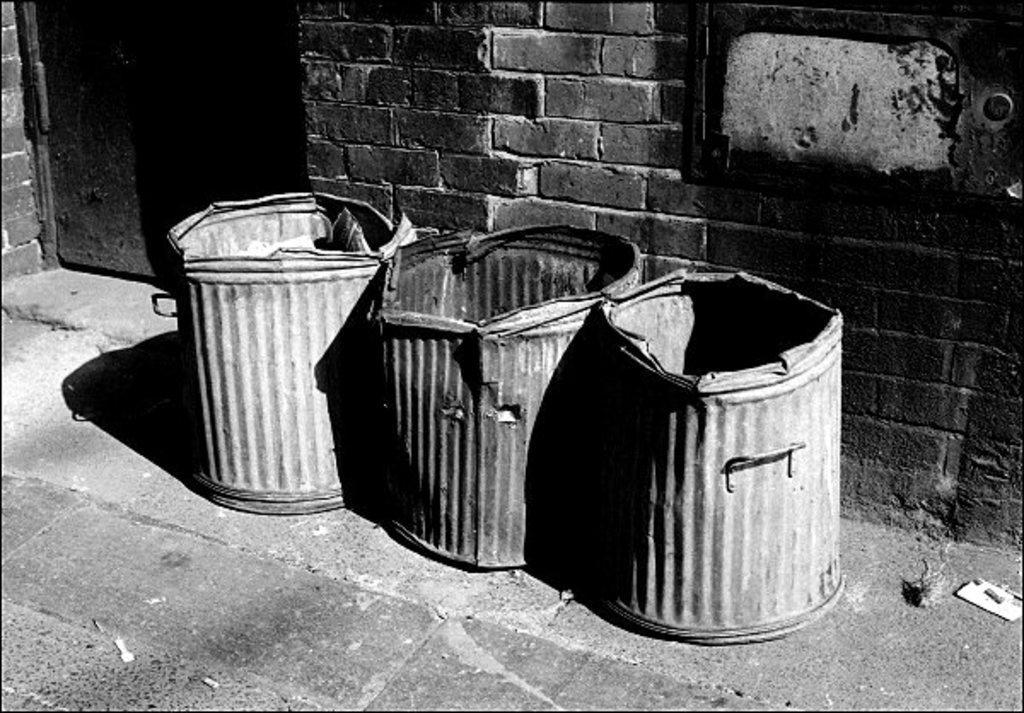Please provide a concise description of this image. This picture is clicked outside. In the foreground we can see the containers are placed on the ground. In the background we can see a door and a brick wall. 